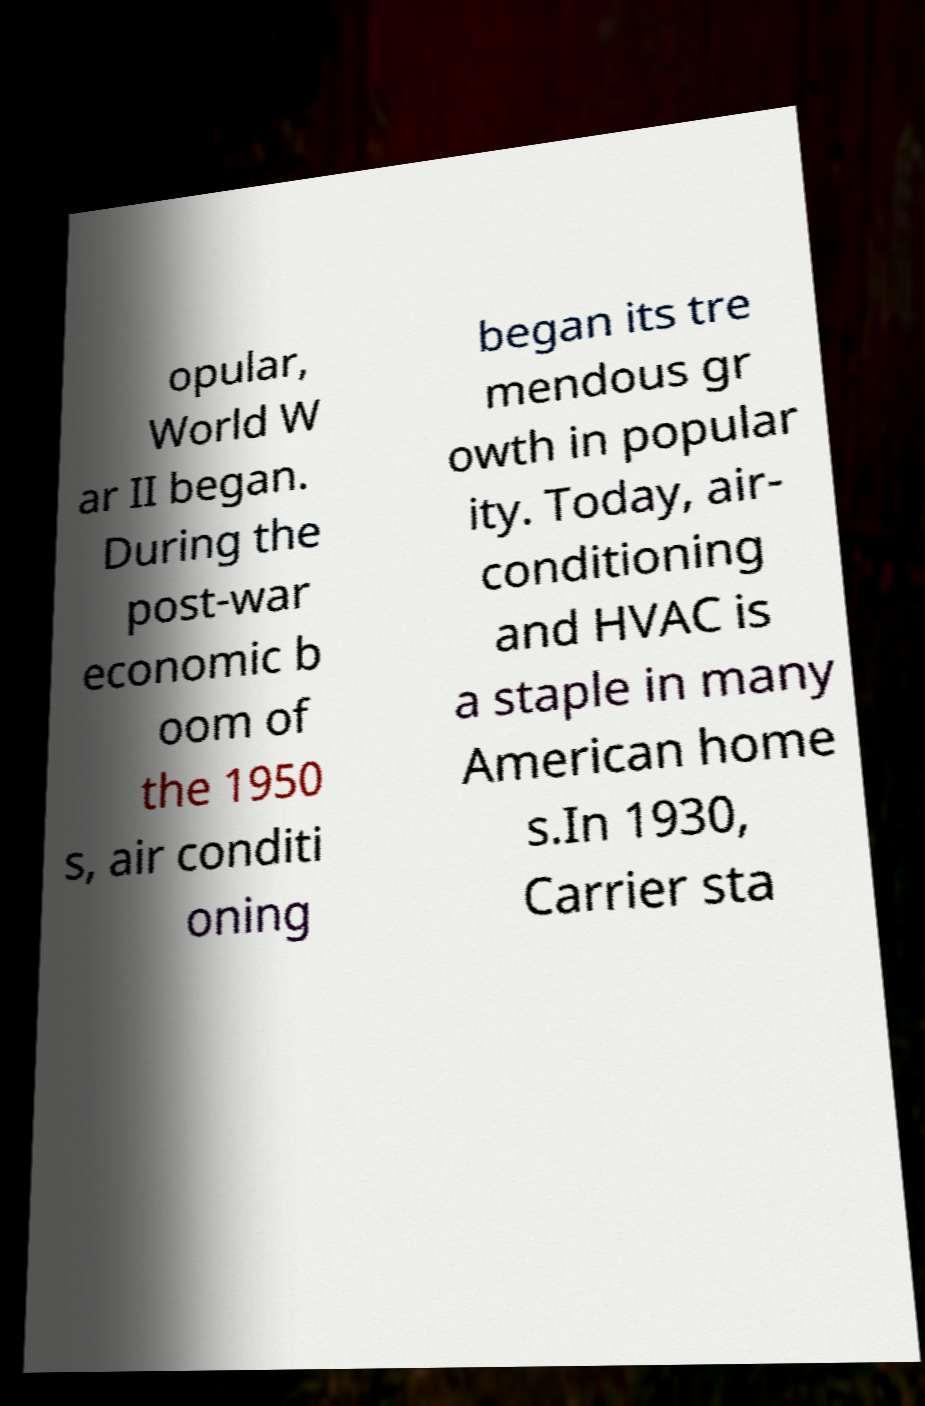Can you accurately transcribe the text from the provided image for me? opular, World W ar II began. During the post-war economic b oom of the 1950 s, air conditi oning began its tre mendous gr owth in popular ity. Today, air- conditioning and HVAC is a staple in many American home s.In 1930, Carrier sta 